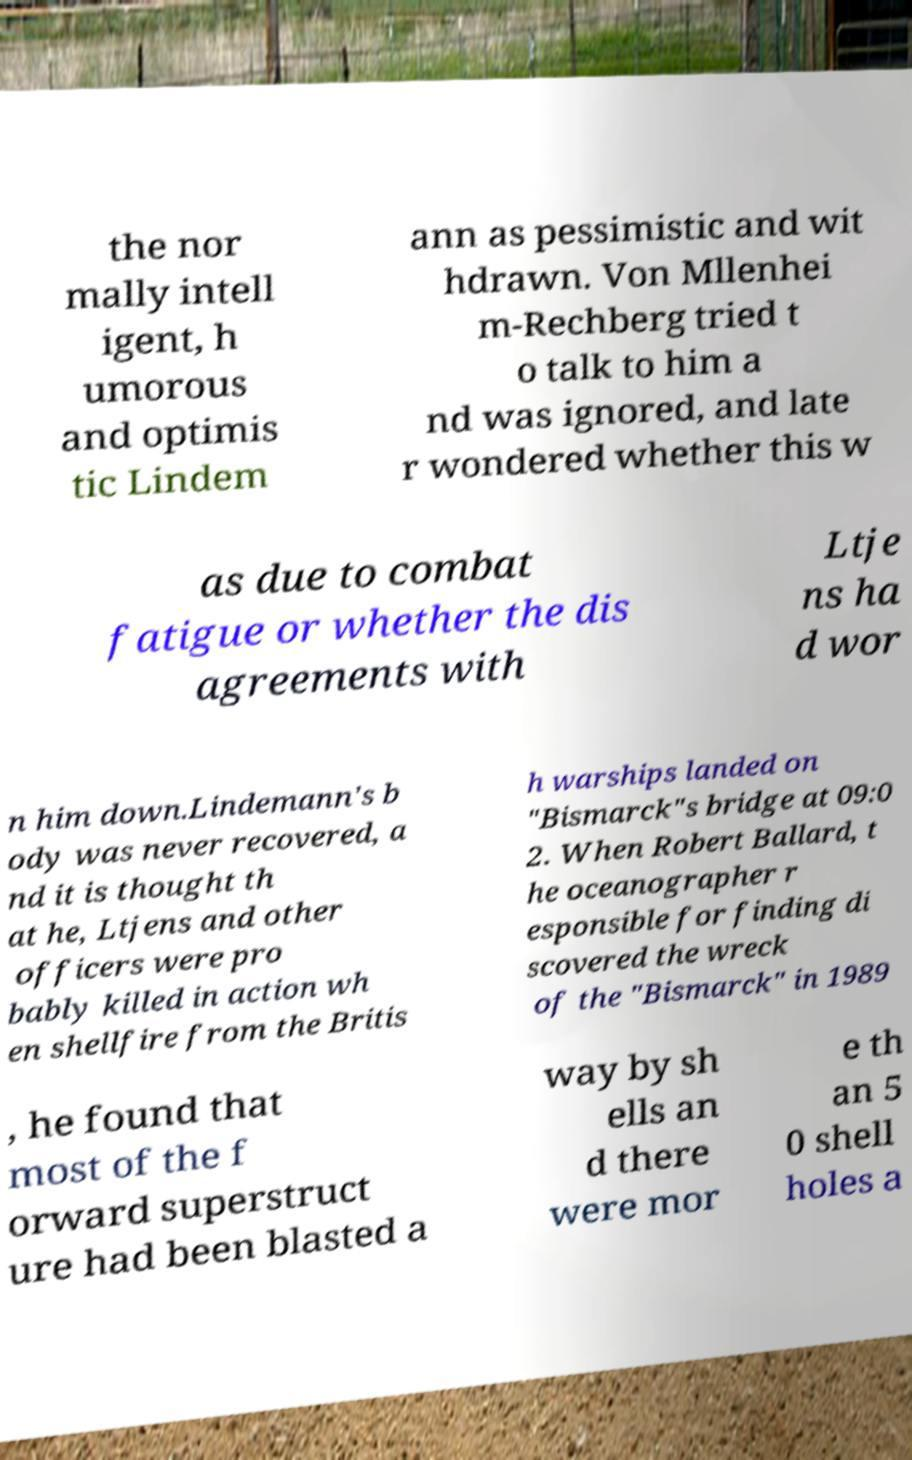Please read and relay the text visible in this image. What does it say? the nor mally intell igent, h umorous and optimis tic Lindem ann as pessimistic and wit hdrawn. Von Mllenhei m-Rechberg tried t o talk to him a nd was ignored, and late r wondered whether this w as due to combat fatigue or whether the dis agreements with Ltje ns ha d wor n him down.Lindemann's b ody was never recovered, a nd it is thought th at he, Ltjens and other officers were pro bably killed in action wh en shellfire from the Britis h warships landed on "Bismarck"s bridge at 09:0 2. When Robert Ballard, t he oceanographer r esponsible for finding di scovered the wreck of the "Bismarck" in 1989 , he found that most of the f orward superstruct ure had been blasted a way by sh ells an d there were mor e th an 5 0 shell holes a 